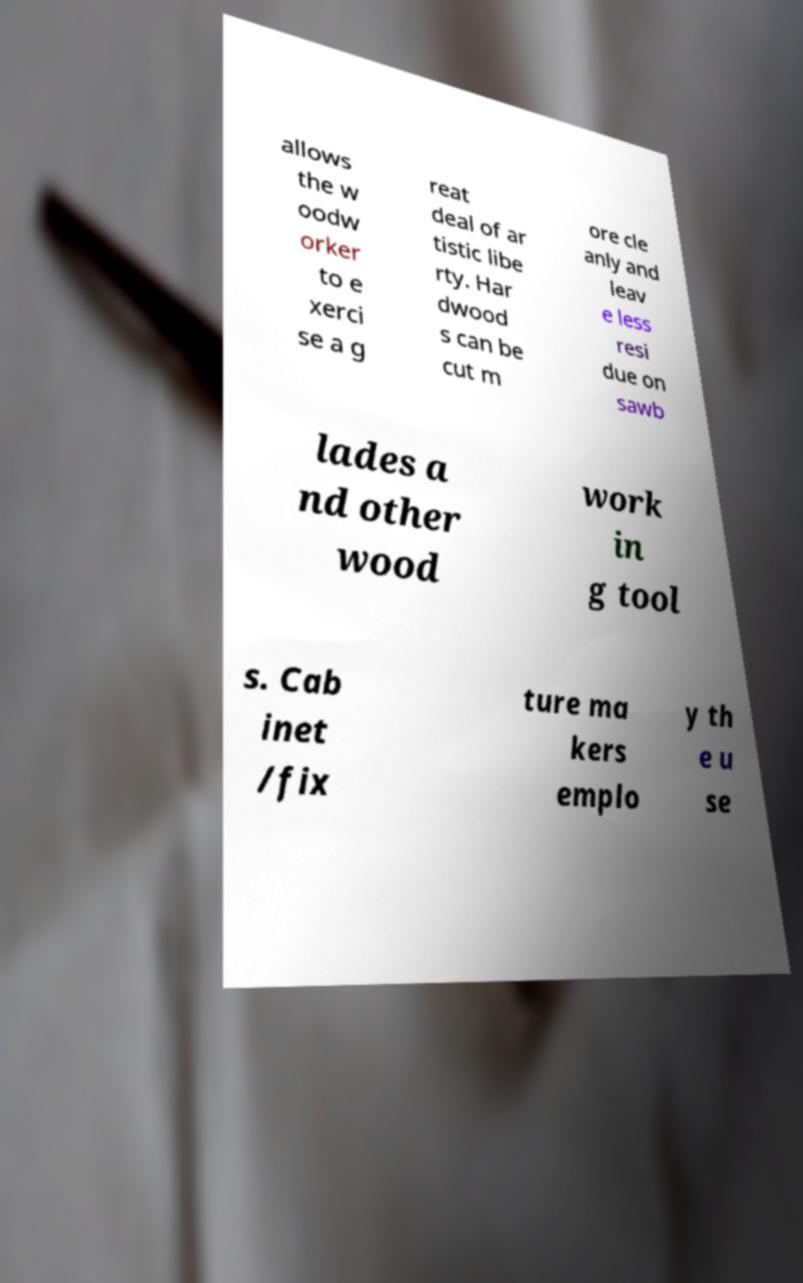Could you extract and type out the text from this image? allows the w oodw orker to e xerci se a g reat deal of ar tistic libe rty. Har dwood s can be cut m ore cle anly and leav e less resi due on sawb lades a nd other wood work in g tool s. Cab inet /fix ture ma kers emplo y th e u se 